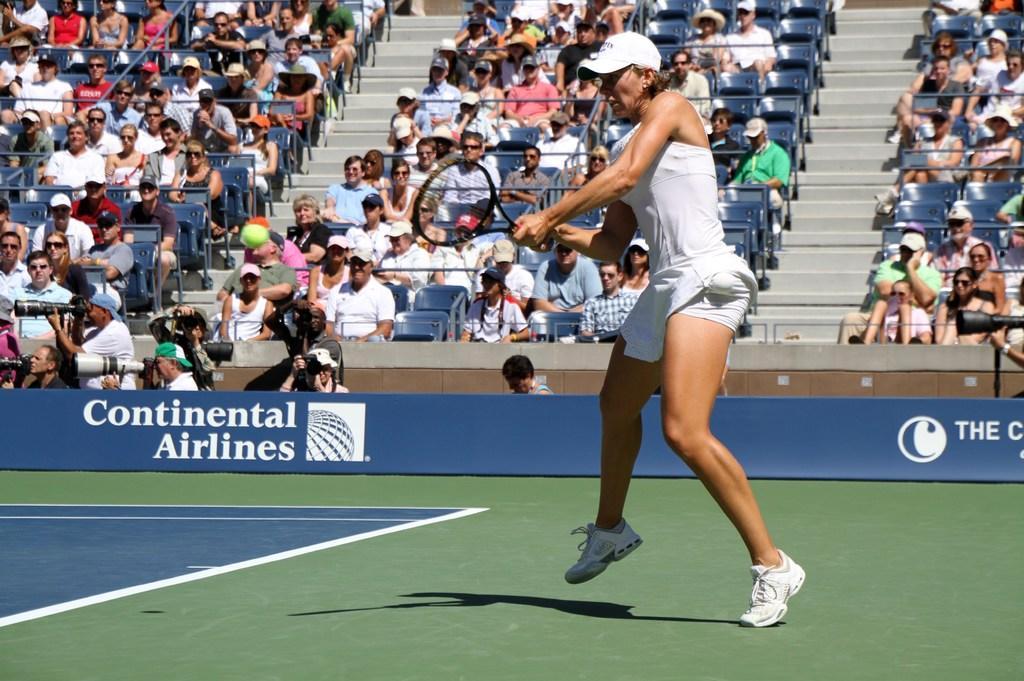In one or two sentences, can you explain what this image depicts? A lady is playing tennis in the court. In the background we observe spectators sitting in the chairs. 